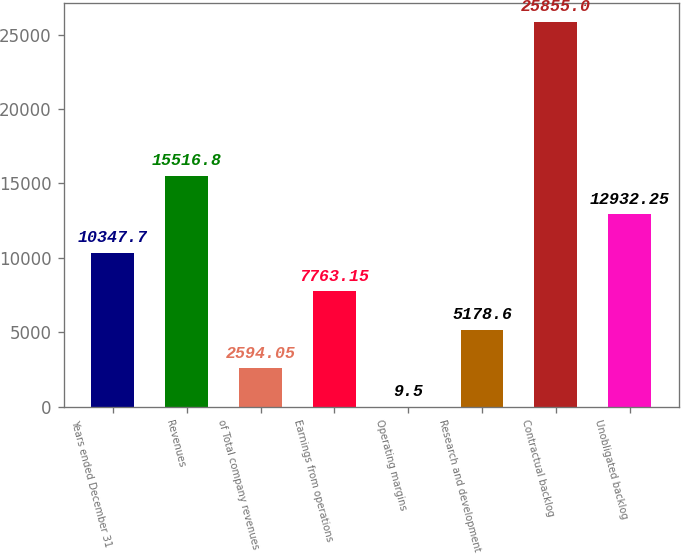Convert chart. <chart><loc_0><loc_0><loc_500><loc_500><bar_chart><fcel>Years ended December 31<fcel>Revenues<fcel>of Total company revenues<fcel>Earnings from operations<fcel>Operating margins<fcel>Research and development<fcel>Contractual backlog<fcel>Unobligated backlog<nl><fcel>10347.7<fcel>15516.8<fcel>2594.05<fcel>7763.15<fcel>9.5<fcel>5178.6<fcel>25855<fcel>12932.2<nl></chart> 